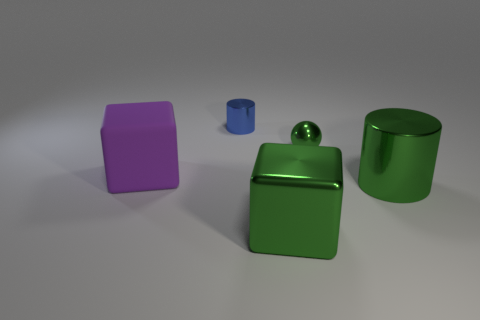How many other things are the same color as the big metal cylinder?
Keep it short and to the point. 2. What material is the purple cube?
Keep it short and to the point. Rubber. What number of tiny green metal things have the same shape as the blue thing?
Ensure brevity in your answer.  0. Are there any other things that have the same shape as the tiny green object?
Provide a succinct answer. No. There is a tiny metallic object in front of the cylinder to the left of the green shiny object that is in front of the green metal cylinder; what is its color?
Your answer should be compact. Green. How many large objects are either red matte balls or green metallic blocks?
Your answer should be compact. 1. Are there an equal number of green metal cubes on the left side of the tiny metal cylinder and balls?
Make the answer very short. No. There is a small green thing; are there any big green metal cylinders behind it?
Make the answer very short. No. How many metal things are either big green cylinders or green cubes?
Give a very brief answer. 2. How many tiny green balls are on the right side of the large purple object?
Provide a short and direct response. 1. 